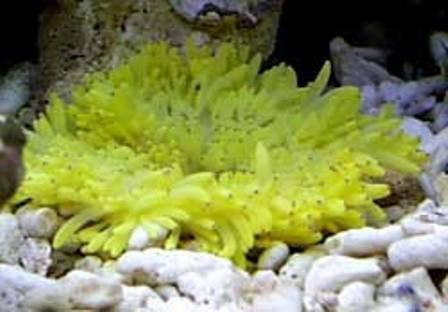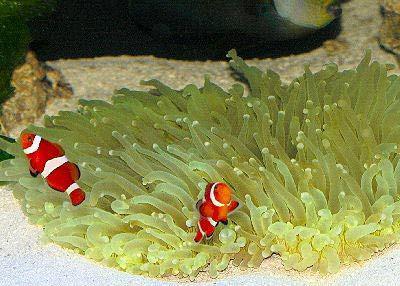The first image is the image on the left, the second image is the image on the right. Assess this claim about the two images: "At least one image shows a bright yellow anemone with tendrils that have a black dot on the end.". Correct or not? Answer yes or no. Yes. The first image is the image on the left, the second image is the image on the right. Examine the images to the left and right. Is the description "The only living thing in one of the images is an anemone." accurate? Answer yes or no. Yes. 